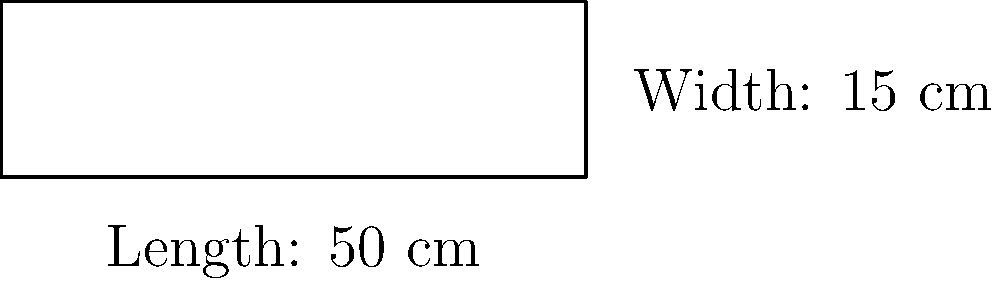As an art historian studying trade goods in ancient artworks, you've come across a detailed depiction of an Egyptian papyrus scroll in a wall painting. The scroll is rectangular in shape, with a length of 50 cm and a width of 15 cm. What is the perimeter of this papyrus scroll? To calculate the perimeter of the rectangular papyrus scroll, we need to follow these steps:

1. Recall the formula for the perimeter of a rectangle:
   $$ P = 2l + 2w $$
   where $P$ is the perimeter, $l$ is the length, and $w$ is the width.

2. Substitute the given values:
   - Length $(l) = 50$ cm
   - Width $(w) = 15$ cm

3. Apply the formula:
   $$ P = 2(50) + 2(15) $$

4. Calculate:
   $$ P = 100 + 30 = 130 $$

Therefore, the perimeter of the papyrus scroll is 130 cm.
Answer: 130 cm 